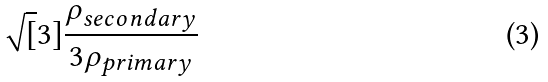Convert formula to latex. <formula><loc_0><loc_0><loc_500><loc_500>\sqrt { [ } 3 ] { \frac { \rho _ { s e c o n d a r y } } { 3 \rho _ { p r i m a r y } } }</formula> 